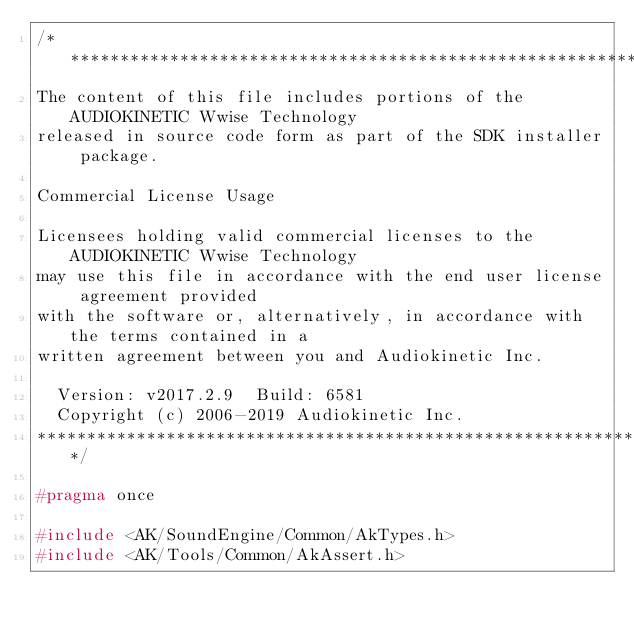<code> <loc_0><loc_0><loc_500><loc_500><_C_>/*******************************************************************************
The content of this file includes portions of the AUDIOKINETIC Wwise Technology
released in source code form as part of the SDK installer package.

Commercial License Usage

Licensees holding valid commercial licenses to the AUDIOKINETIC Wwise Technology
may use this file in accordance with the end user license agreement provided 
with the software or, alternatively, in accordance with the terms contained in a
written agreement between you and Audiokinetic Inc.

  Version: v2017.2.9  Build: 6581
  Copyright (c) 2006-2019 Audiokinetic Inc.
*******************************************************************************/

#pragma once

#include <AK/SoundEngine/Common/AkTypes.h>
#include <AK/Tools/Common/AkAssert.h>
</code> 